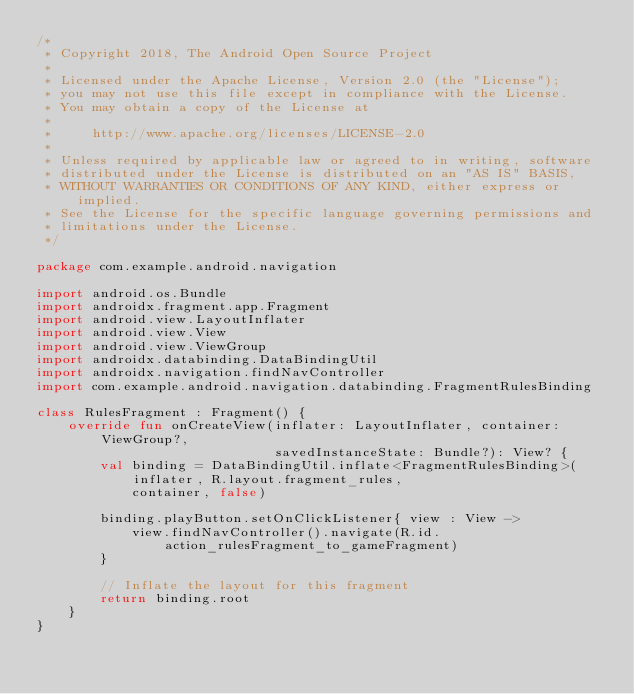Convert code to text. <code><loc_0><loc_0><loc_500><loc_500><_Kotlin_>/*
 * Copyright 2018, The Android Open Source Project
 *
 * Licensed under the Apache License, Version 2.0 (the "License");
 * you may not use this file except in compliance with the License.
 * You may obtain a copy of the License at
 *
 *     http://www.apache.org/licenses/LICENSE-2.0
 *
 * Unless required by applicable law or agreed to in writing, software
 * distributed under the License is distributed on an "AS IS" BASIS,
 * WITHOUT WARRANTIES OR CONDITIONS OF ANY KIND, either express or implied.
 * See the License for the specific language governing permissions and
 * limitations under the License.
 */

package com.example.android.navigation

import android.os.Bundle
import androidx.fragment.app.Fragment
import android.view.LayoutInflater
import android.view.View
import android.view.ViewGroup
import androidx.databinding.DataBindingUtil
import androidx.navigation.findNavController
import com.example.android.navigation.databinding.FragmentRulesBinding

class RulesFragment : Fragment() {
    override fun onCreateView(inflater: LayoutInflater, container: ViewGroup?,
                              savedInstanceState: Bundle?): View? {
        val binding = DataBindingUtil.inflate<FragmentRulesBinding>(inflater, R.layout.fragment_rules,
            container, false)

        binding.playButton.setOnClickListener{ view : View ->
            view.findNavController().navigate(R.id.action_rulesFragment_to_gameFragment)
        }

        // Inflate the layout for this fragment
        return binding.root
    }
}
</code> 